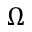<formula> <loc_0><loc_0><loc_500><loc_500>\Omega</formula> 